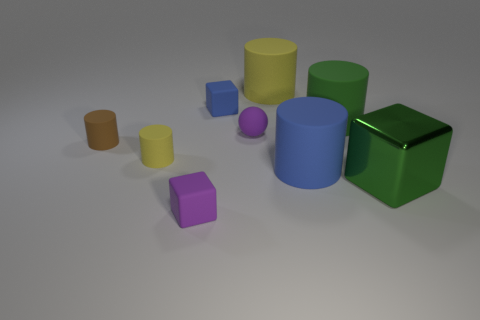Is there any other thing that has the same material as the big block?
Provide a succinct answer. No. What number of small objects have the same color as the sphere?
Keep it short and to the point. 1. Is there a green matte object that has the same size as the rubber sphere?
Give a very brief answer. No. What material is the purple cube that is the same size as the rubber sphere?
Your response must be concise. Rubber. There is a yellow thing behind the tiny matte ball; does it have the same size as the purple thing that is right of the purple rubber cube?
Offer a terse response. No. What number of things are rubber cubes or yellow things left of the big yellow matte object?
Give a very brief answer. 3. Is there a small brown thing that has the same shape as the big blue thing?
Your response must be concise. Yes. There is a purple object that is in front of the yellow thing left of the small purple matte ball; what size is it?
Give a very brief answer. Small. How many metallic things are small blocks or big blue objects?
Keep it short and to the point. 0. What number of large gray spheres are there?
Ensure brevity in your answer.  0. 